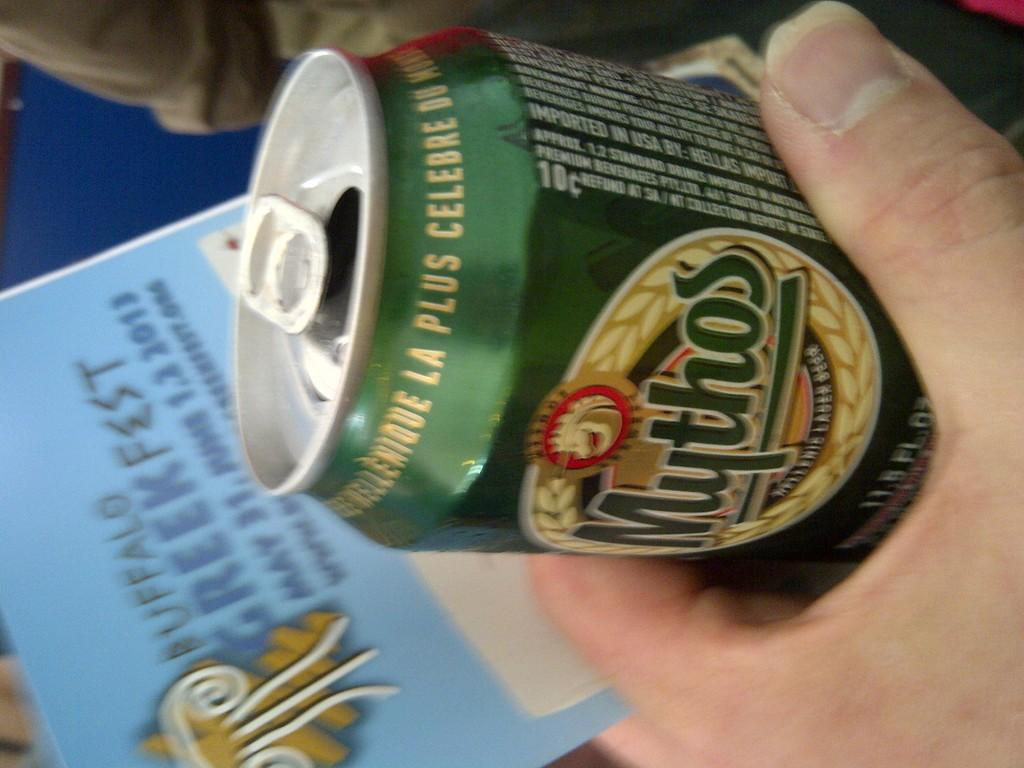<image>
Share a concise interpretation of the image provided. a person is holding a can of Mythos drink in their hand 